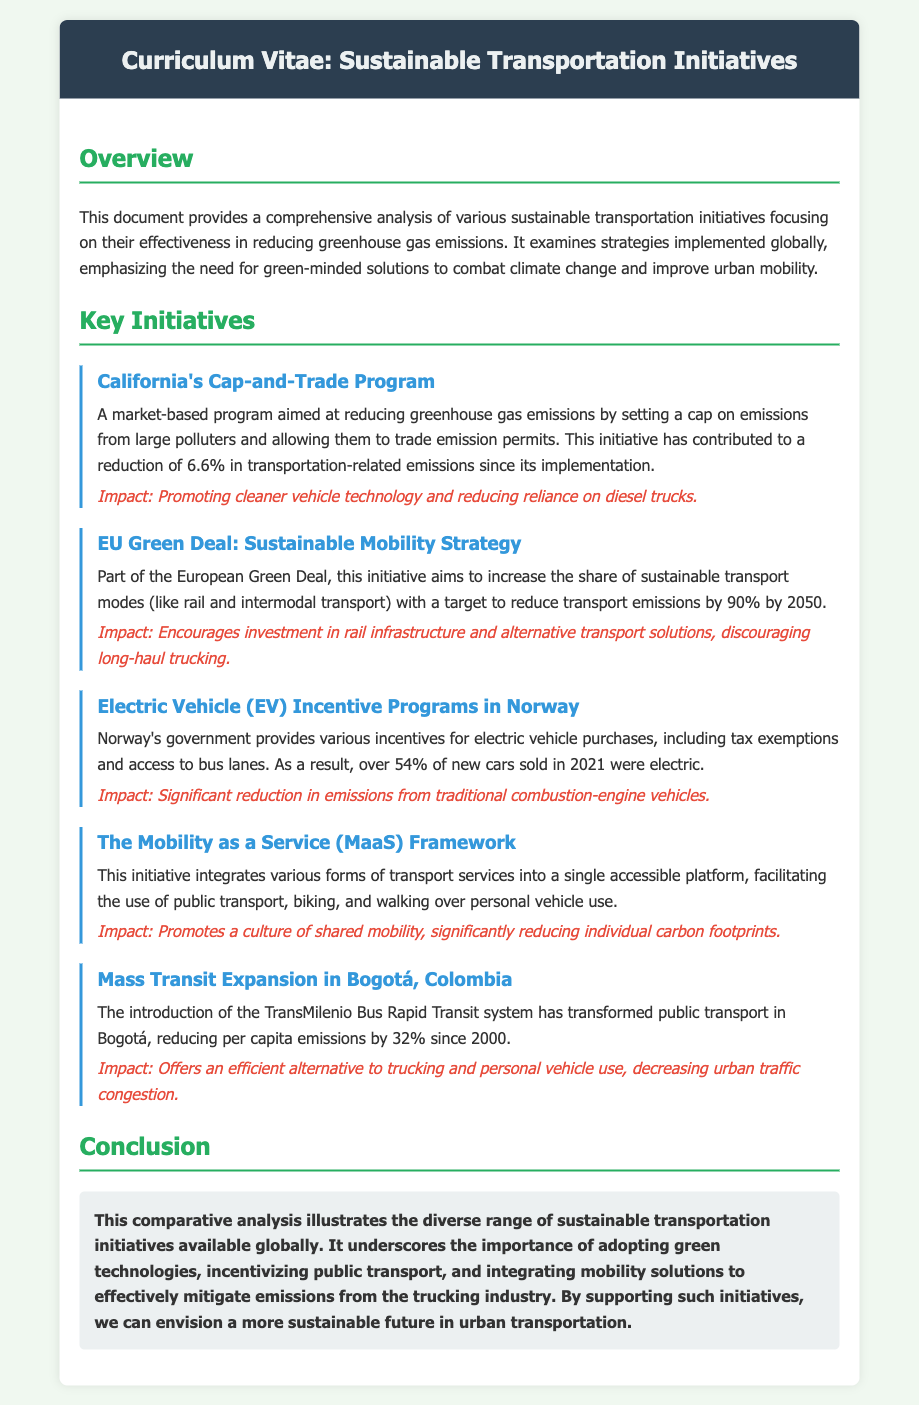What is the cap reduction percentage achieved by California's program? California's Cap-and-Trade Program has contributed to a reduction of 6.6% in transportation-related emissions.
Answer: 6.6% What is the target percentage for emission reduction in the EU Green Deal by 2050? The EU Green Deal aims to reduce transport emissions by 90% by 2050.
Answer: 90% Which country has EV incentive programs that led to over 54% of new car sales being electric? Norway's government provides various incentives for electric vehicle purchases.
Answer: Norway What does the Mobility as a Service (MaaS) initiative promote? The initiative promotes a culture of shared mobility, significantly reducing individual carbon footprints.
Answer: Shared mobility What is the reduction in per capita emissions achieved by Bogotá's TransMilenio system since 2000? The introduction of the TransMilenio Bus Rapid Transit system has reduced per capita emissions by 32% since 2000.
Answer: 32% Which initiative encourages investment in rail infrastructure? The EU Green Deal: Sustainable Mobility Strategy encourages investment in rail infrastructure.
Answer: EU Green Deal What does the conclusion emphasize about mitigating emissions? The conclusion underscores the importance of adopting green technologies, incentivizing public transport, and integrating mobility solutions.
Answer: Green technologies, public transport, mobility solutions In which section would you find the impact of California's Cap-and-Trade Program? The impact of California's Cap-and-Trade Program can be found in the "Key Initiatives" section.
Answer: Key Initiatives What is the document type of this analysis? The document provides a comprehensive analysis of sustainable transportation initiatives.
Answer: Curriculum Vitae 